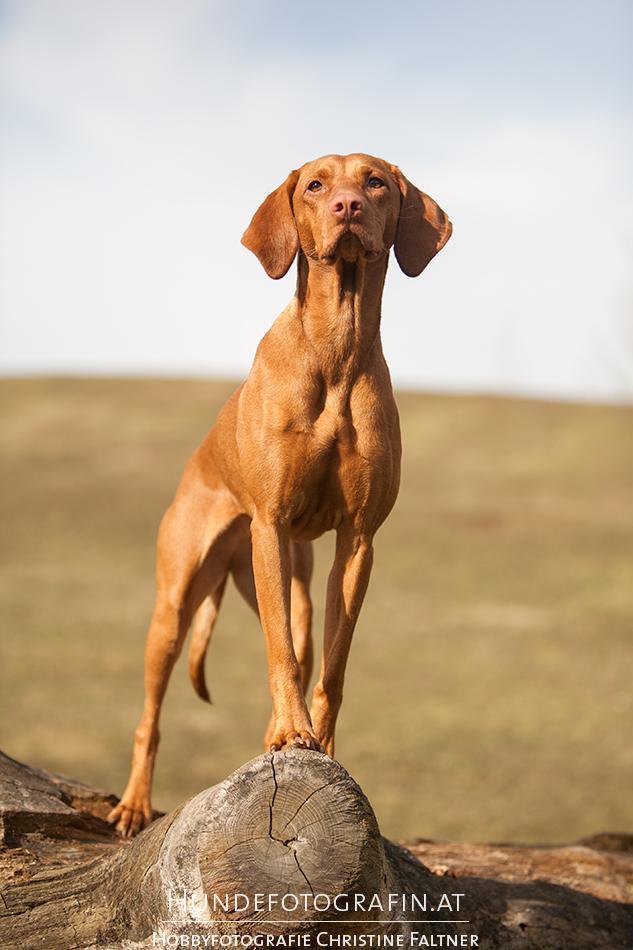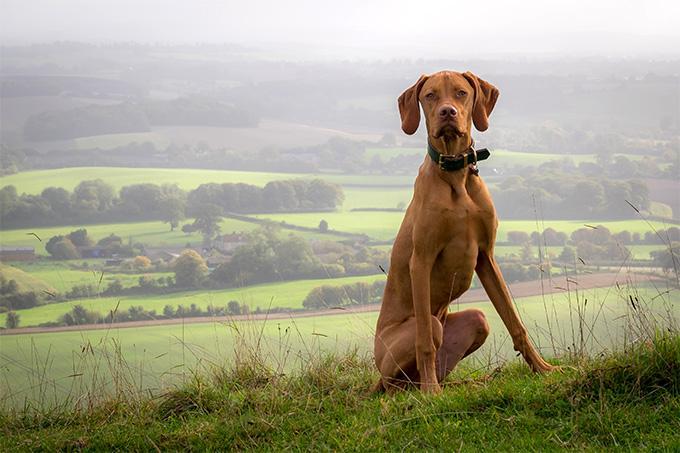The first image is the image on the left, the second image is the image on the right. Analyze the images presented: Is the assertion "In at least one image there is a red hound with a collar sitting in the grass." valid? Answer yes or no. Yes. The first image is the image on the left, the second image is the image on the right. Analyze the images presented: Is the assertion "There are three animals." valid? Answer yes or no. No. 